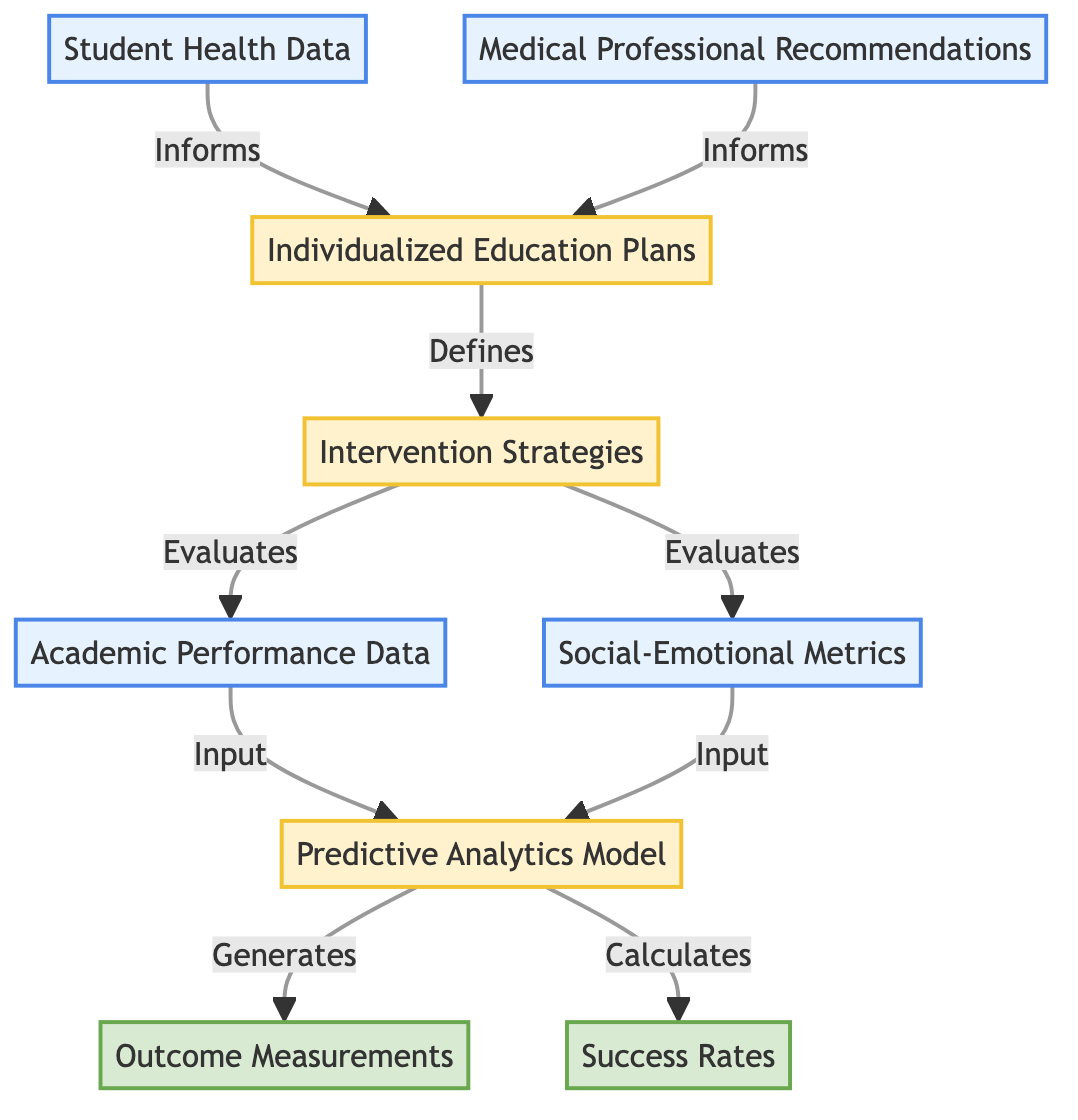What is the starting input in the diagram? The first input node in the diagram is labeled "Student Health Data." This node represents initial information that informs the creation of Individualized Education Plans.
Answer: Student Health Data How many input nodes are present in the diagram? The diagram contains four input nodes, namely "Student Health Data," "Medical Professional Recommendations," "Academic Performance Data," and "Social-Emotional Metrics."
Answer: 4 Which node defines the Intervention Strategies? The node "Individualized Education Plans" is the one that defines the Intervention Strategies in the flow of the diagram. It is crucial as it is influenced by the input data from medical professionals and student health.
Answer: Individualized Education Plans What is generated by the Predictive Analytics Model? The Predictive Analytics Model generates "Outcome Measurements" based on the data inputs from academic performance and social-emotional metrics, indicating the effectiveness of various educational interventions.
Answer: Outcome Measurements What is the relationship between the Intervention Strategies and the Academic Performance Data? The Intervention Strategies evaluate the Academic Performance Data, assessing the impact of the interventions on student achievement and performance metrics.
Answer: Evaluates Which node calculates success rates? The node named "Predictive Analytics Model" is responsible for calculating success rates based on the input data it receives from Intervention Strategies and Outcome Measurements.
Answer: Predictive Analytics Model What is ultimately derived from the Predictive Analytics Model? From the Predictive Analytics Model, two outcomes are ultimately derived: "Outcome Measurements" and "Success Rates," which assess the effectiveness of the interventions.
Answer: Outcome Measurements and Success Rates Which nodes inform the Individualized Education Plans? Both "Student Health Data" and "Medical Professional Recommendations" inform the Individualized Education Plans, ensuring that they are tailored to meet the specific needs identified by medical professionals.
Answer: Student Health Data and Medical Professional Recommendations 